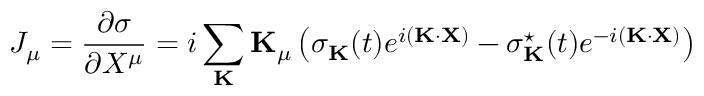Convert formula to latex. <formula><loc_0><loc_0><loc_500><loc_500>J _ { \mu } = \frac { \partial \sigma } { \partial X ^ { \mu } } = i \sum _ { K } { K } _ { \mu } \left ( \sigma _ { K } ( t ) e ^ { i ( { K } \cdot { X } ) } - \sigma _ { K } ^ { ^ { * } } ( t ) e ^ { - i ( { K } \cdot { X } ) } \right )</formula> 